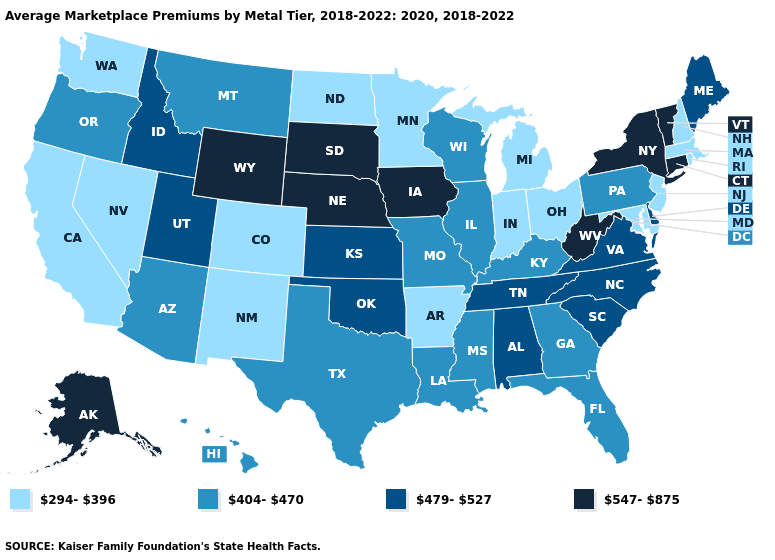What is the value of Iowa?
Answer briefly. 547-875. Is the legend a continuous bar?
Answer briefly. No. What is the lowest value in the USA?
Answer briefly. 294-396. What is the lowest value in the West?
Write a very short answer. 294-396. Among the states that border New Hampshire , which have the highest value?
Quick response, please. Vermont. Which states have the highest value in the USA?
Short answer required. Alaska, Connecticut, Iowa, Nebraska, New York, South Dakota, Vermont, West Virginia, Wyoming. What is the lowest value in the West?
Concise answer only. 294-396. Does Hawaii have the highest value in the West?
Write a very short answer. No. Name the states that have a value in the range 294-396?
Give a very brief answer. Arkansas, California, Colorado, Indiana, Maryland, Massachusetts, Michigan, Minnesota, Nevada, New Hampshire, New Jersey, New Mexico, North Dakota, Ohio, Rhode Island, Washington. Among the states that border Missouri , does Arkansas have the lowest value?
Give a very brief answer. Yes. What is the value of Rhode Island?
Quick response, please. 294-396. Does Louisiana have a lower value than New Mexico?
Write a very short answer. No. What is the value of Maryland?
Keep it brief. 294-396. Among the states that border Michigan , does Wisconsin have the lowest value?
Concise answer only. No. Which states have the lowest value in the USA?
Quick response, please. Arkansas, California, Colorado, Indiana, Maryland, Massachusetts, Michigan, Minnesota, Nevada, New Hampshire, New Jersey, New Mexico, North Dakota, Ohio, Rhode Island, Washington. 